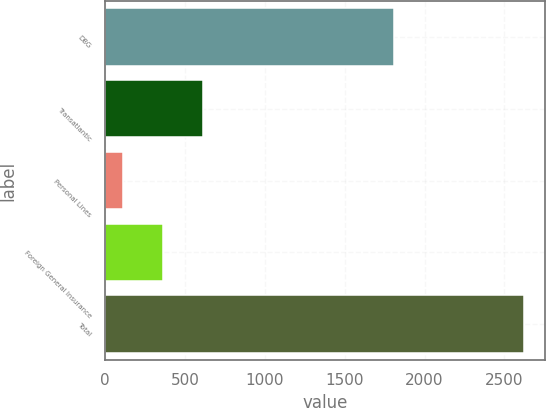<chart> <loc_0><loc_0><loc_500><loc_500><bar_chart><fcel>DBG<fcel>Transatlantic<fcel>Personal Lines<fcel>Foreign General Insurance<fcel>Total<nl><fcel>1811<fcel>614.6<fcel>112<fcel>363.3<fcel>2625<nl></chart> 